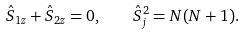Convert formula to latex. <formula><loc_0><loc_0><loc_500><loc_500>\hat { S } _ { 1 z } + \hat { S } _ { 2 z } = 0 , \quad \hat { S } _ { j } ^ { 2 } = N ( N + 1 ) .</formula> 